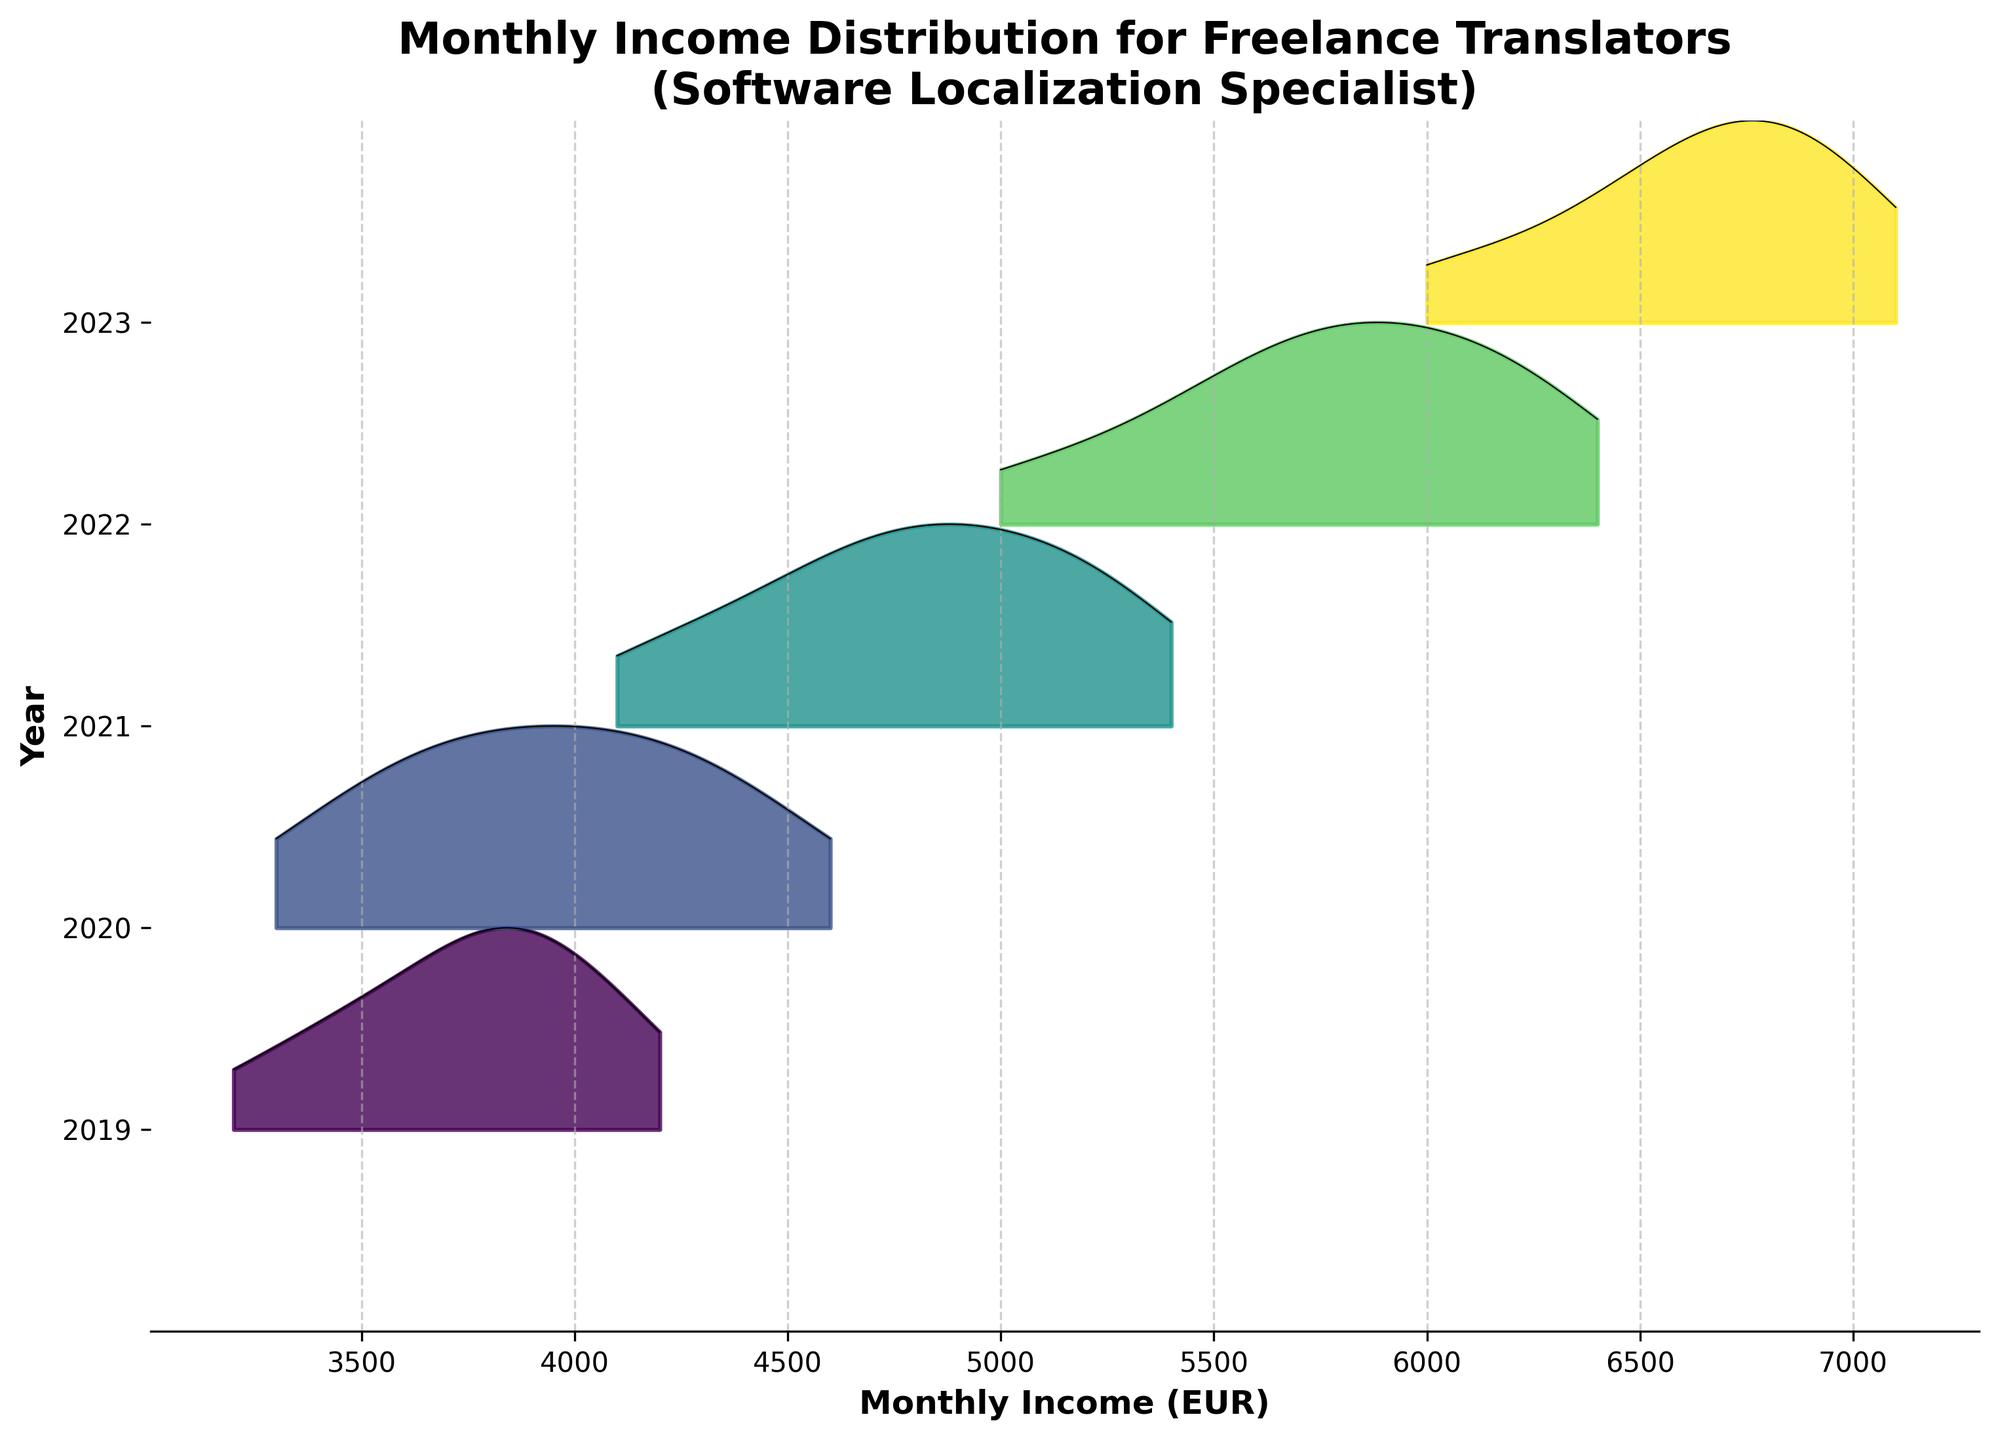What is the title of the plot? The title is usually found at the top of the figure, summarizing what the plot is about. Here, it indicates the subject and scope of data shown, which is "Monthly Income Distribution for Freelance Translators (Software Localization Specialist)."
Answer: Monthly Income Distribution for Freelance Translators (Software Localization Specialist) How many years of data are displayed in the plot? The plot uses a distinct color for each year, with corresponding labels on the y-axis. By counting the number of unique y-axis labels, you can determine the number of years represented.
Answer: 5 Which year recorded the highest overall income? Examine the data distributions for each year along the x-axis and look for the furthest right or highest peak. The last year's distribution, indicated in a dark color, reaches a higher maximum income.
Answer: 2023 What was the approximate maximum monthly income in 2021? Identify the range of the 2021 distribution along the x-axis, noting where it reaches its highest point. The peak should be near the labeled x-ticks around this range.
Answer: 5400 EUR Which year had the least amount of income variability? Look for the year with the narrowest distribution curve, indicating less fluctuation in income. This can be inferred by comparing the widths of the filled-in areas for each year.
Answer: 2019 How did the average income change from 2019 to 2023? To find the average change, compare the approximate centers of the income distributions for 2019 and 2023 by visually estimating their midpoints along the x-axis.
Answer: Increased Around what value does the majority of monthly incomes fall in 2020? Assess the distribution for 2020, noting where the distribution peak is highest, indicating the most common income levels. It should be where the curve's height is greatest.
Answer: Around 4100 EUR Compare the income distributions of 2021 and 2022. Which year experienced higher incomes generally? Look at the overall positioning of the 2021 and 2022 curves along the x-axis. The curve for 2022 will be shifted to the right if it experienced generally higher incomes.
Answer: 2022 Which month in 2023 had exceptionally high incomes compared to other months in the same year? Although month-specific questions are less direct in a Ridgeline plot, you can still observe if any part of the 2023 distribution stands out, indicating an outlier month. Look for sharp peaks within the 2023 distribution area.
Answer: April What trend can be observed regarding the income distributions over the five years? Evaluate the progressions of the distribution curves from 2019 to 2023. Note if there is a general shift to the right, indicating an overall increase in monthly incomes over the years.
Answer: Increasing trend 